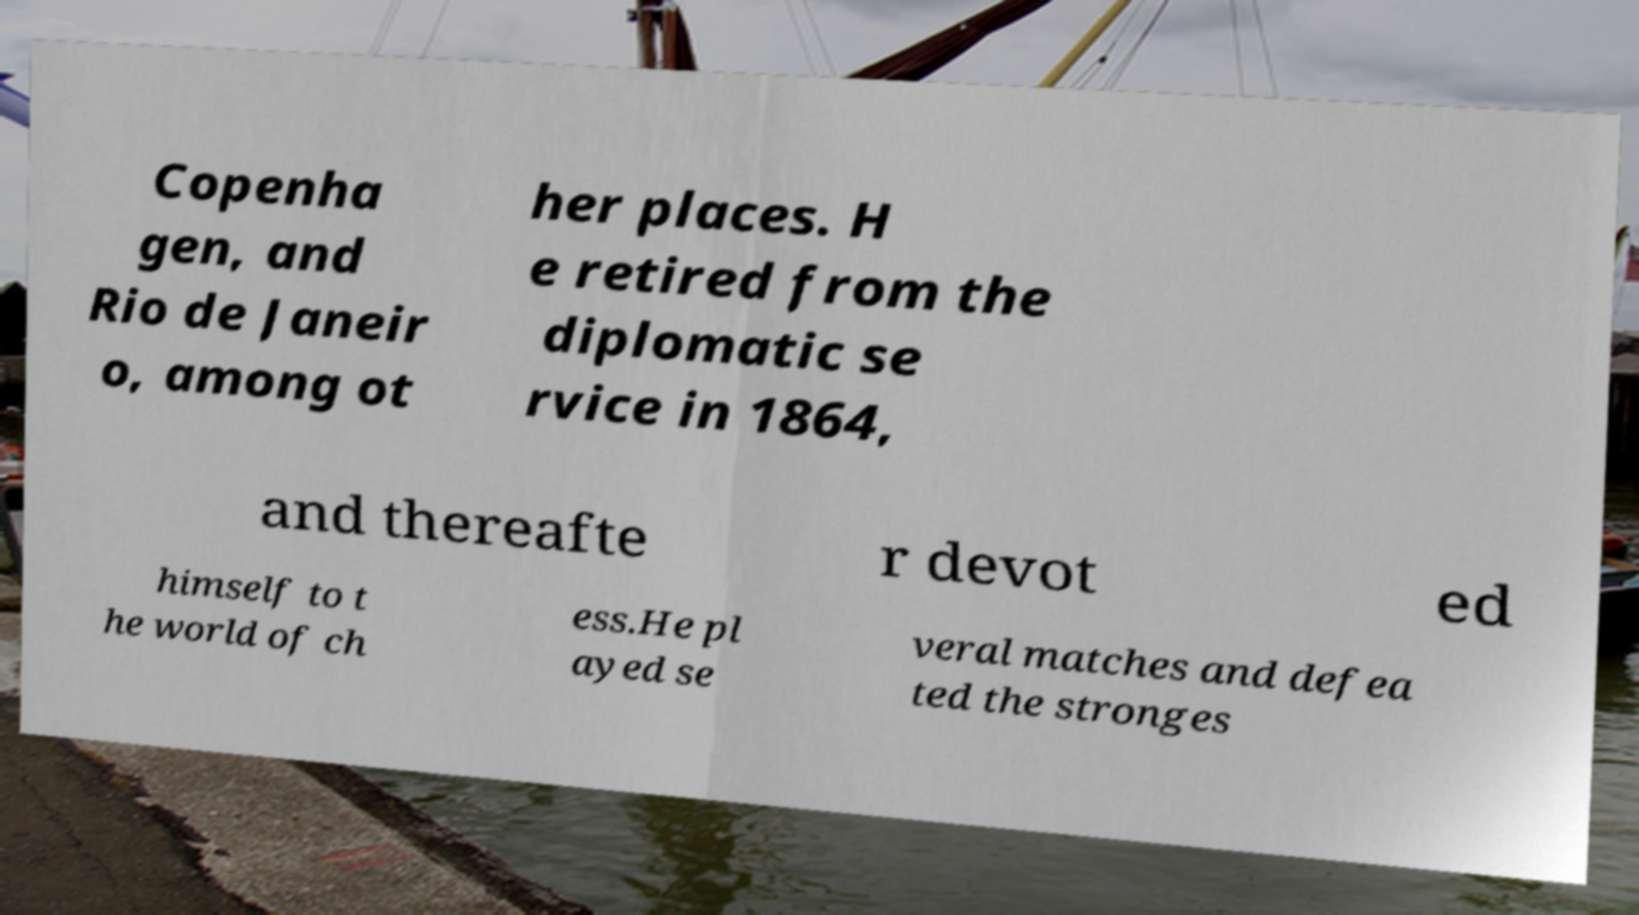Can you read and provide the text displayed in the image?This photo seems to have some interesting text. Can you extract and type it out for me? Copenha gen, and Rio de Janeir o, among ot her places. H e retired from the diplomatic se rvice in 1864, and thereafte r devot ed himself to t he world of ch ess.He pl ayed se veral matches and defea ted the stronges 